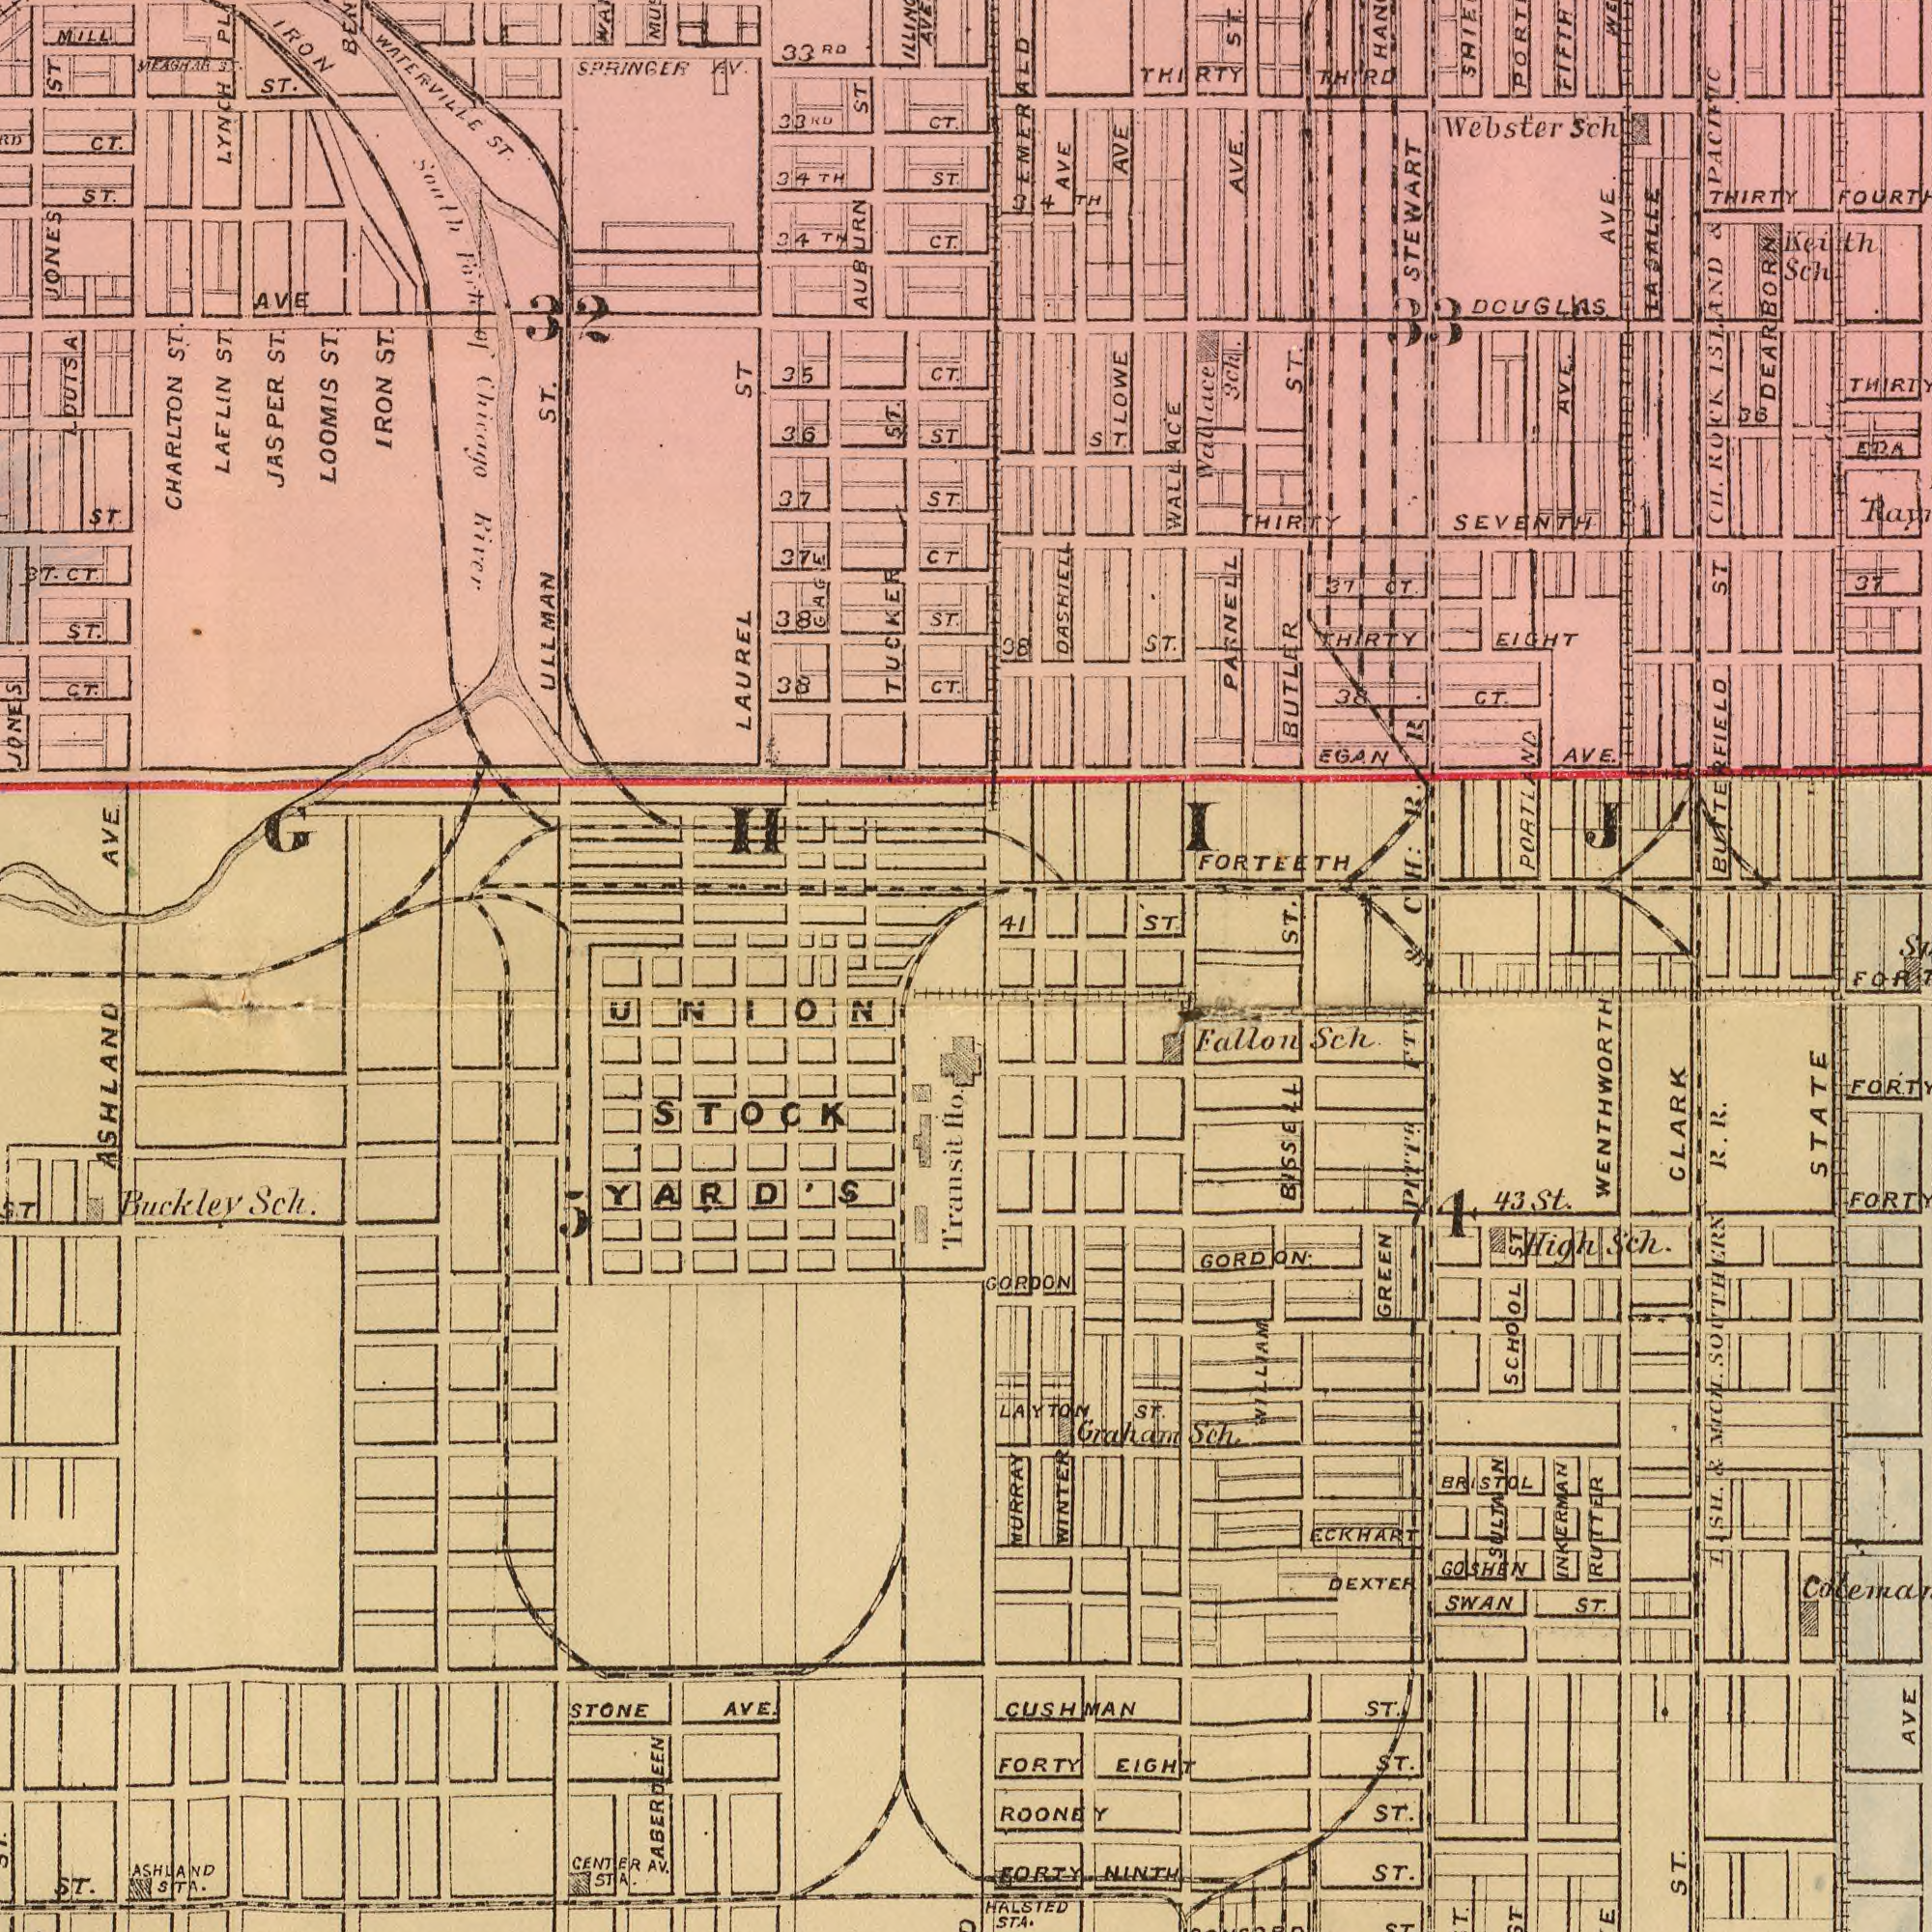What text is shown in the top-left quadrant? LOOMIS LAUREL TUCKER CHARLTON JONES Chirago ST. ST. CT. LAELIN LYNCH ST. ST LOUISA ST. ST. MILL ST. AUBURN 35 River ST. ST. ST. AVE 38 ST. JONES IRON 36 ST CT. ST. CT IRON CT. 33<sup>RD</sup> 37 CT. CT. ST. CT. AVE. ST. 37 JASPER 34<sup>TH</sup> GHIJ WATERVILLE AV. ST. 38 South ST. ST. SPRINGER 34<sup>TH</sup> ST. GAGE ST. of ULLMAN 33<sup>RD</sup> CT. ST. 32 What text appears in the top-right area of the image? PARNELL FORTEETH DASHIELL STEWART ISLAND Webster AVE. DOUGLAS AVE. DEARBORN BUTLER AVE ROCK CH. AVE. SEVENTH ST. AVE. PACIFIC AVE EIGHT THIRTY ST. EGAN THIRTY ST. ST EDA CT. Sch. CH : Sch Sch LASALLE ST. THIRD WALLACE 36 ST. THIRTY 38 37 CT. BUTTERFIELD 41 EMERALD Wallace 37 & ST. Keith LOWE 38 THIRTY PORTLAND FIFTH & R. R 34<sup>TH</sup> 33 What text is shown in the bottom-right quadrant? STATE CLARK INKERMAN WINTER GREEN DEXTER NINTH FORTY BISSELL Sch. AVE Fallon High Graham ECKHART GORDON. SCHOOL ST. SULTAN ST. & CUSHMAN Sch 43 MURRAY EIGHT St. GORDON LAYTON SWAN ST. Sch. 4 GOSHEN SOUTHERN PITT<sup>H</sup>. MCN. I. R. WENTHWORTH FORTY ST. BRISTOL WILLIAM RUTTER ST R. F<sup>TH</sup>. SH. ST. ST. ST. ROONEY HALSTED STA. What text is visible in the lower-left corner? ASHLAND STOCK Buckley ST. AVE. Transit Sch. Ho. STONE UNION YARD'S 5 ASERJEEN CENTER AV. STA. ASHLAND STA. 